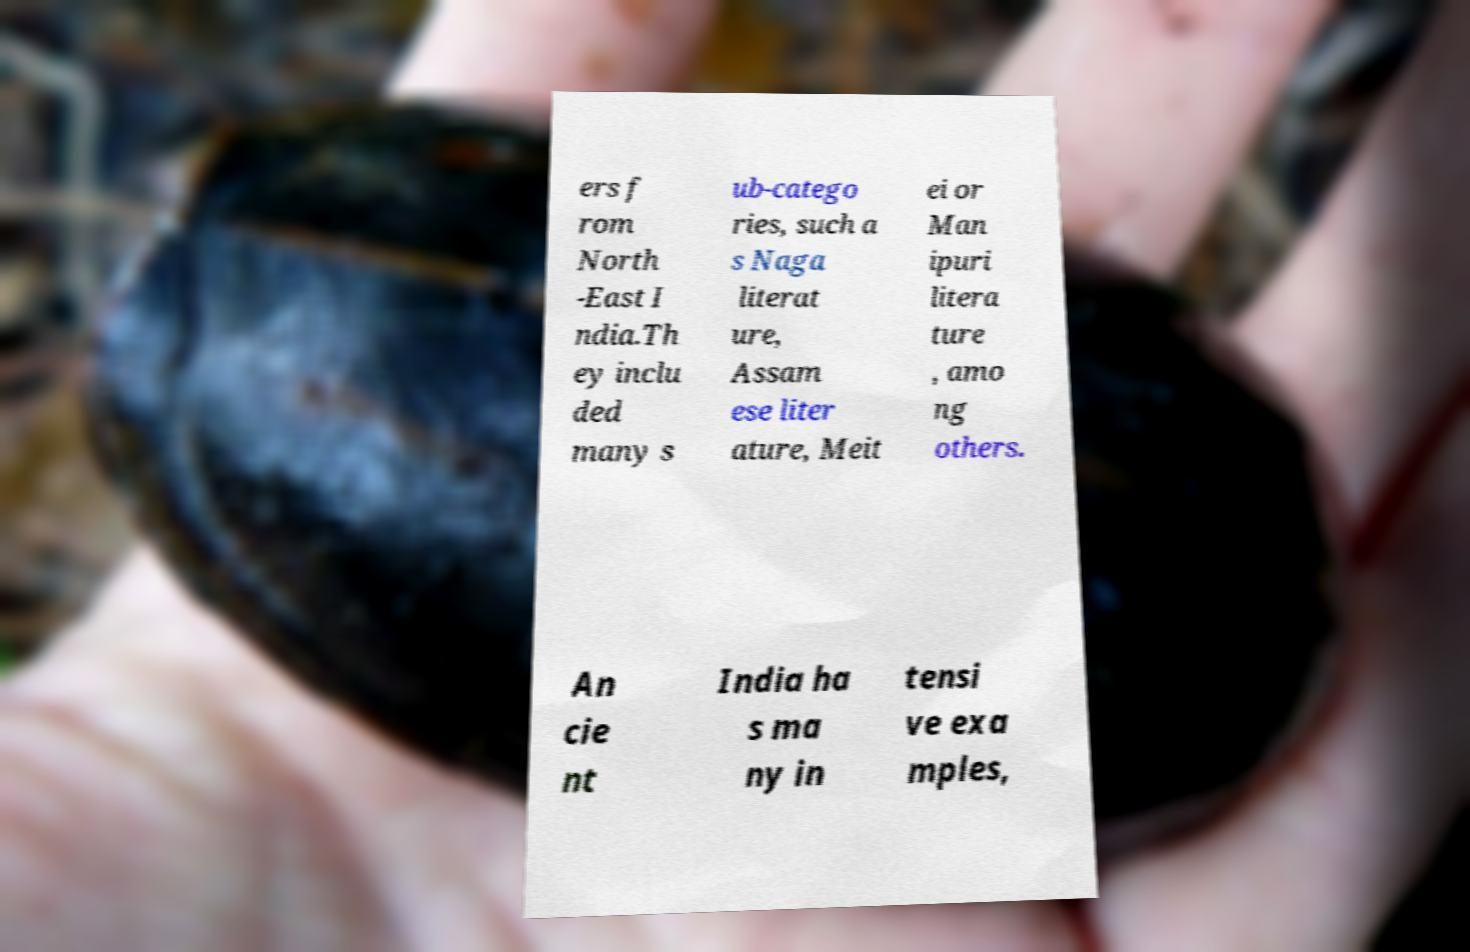Could you assist in decoding the text presented in this image and type it out clearly? ers f rom North -East I ndia.Th ey inclu ded many s ub-catego ries, such a s Naga literat ure, Assam ese liter ature, Meit ei or Man ipuri litera ture , amo ng others. An cie nt India ha s ma ny in tensi ve exa mples, 